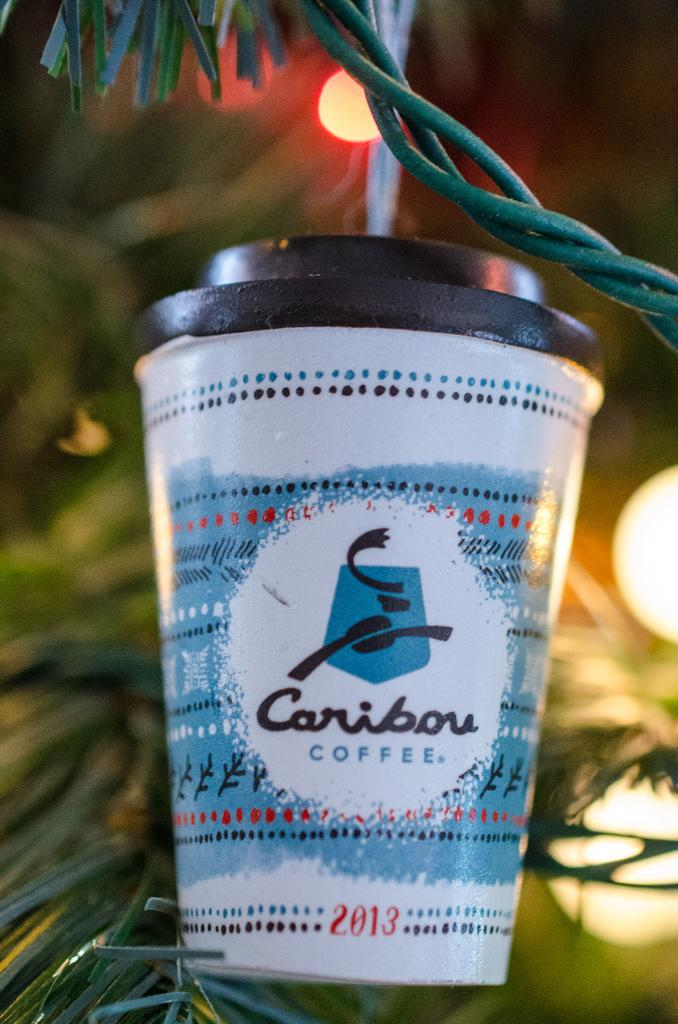<image>
Create a compact narrative representing the image presented. A Christmas ornament of a caribou coffee cup form 2013. 